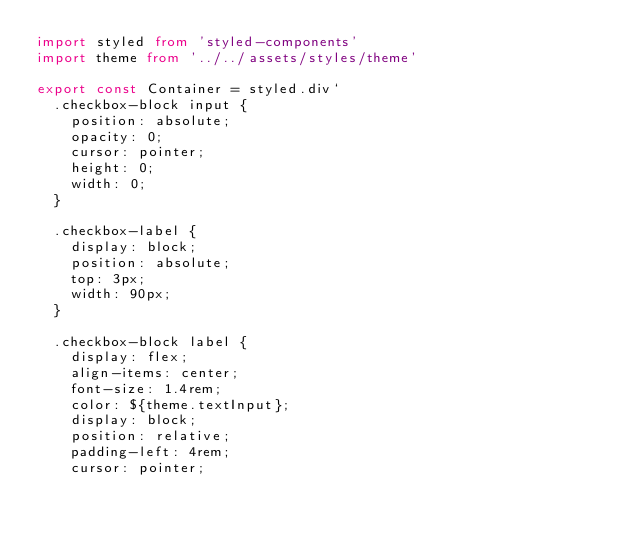<code> <loc_0><loc_0><loc_500><loc_500><_TypeScript_>import styled from 'styled-components'
import theme from '../../assets/styles/theme'

export const Container = styled.div`
  .checkbox-block input {
    position: absolute;
    opacity: 0;
    cursor: pointer;
    height: 0;
    width: 0;
  }

  .checkbox-label {
    display: block;
    position: absolute;
    top: 3px;
    width: 90px;
  }

  .checkbox-block label {
    display: flex;
    align-items: center;
    font-size: 1.4rem;
    color: ${theme.textInput};
    display: block;
    position: relative;
    padding-left: 4rem;
    cursor: pointer;</code> 